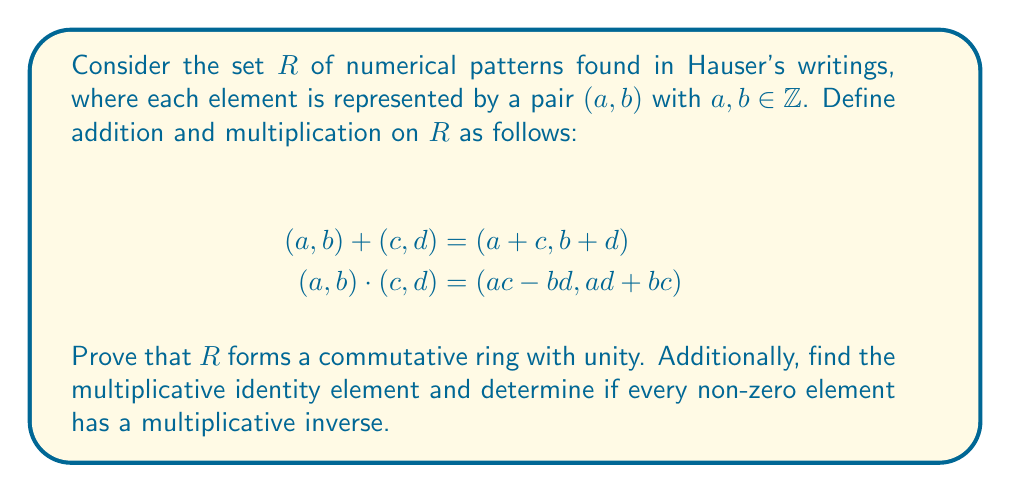Can you answer this question? To prove that $R$ forms a commutative ring with unity, we need to verify the following properties:

1. $(R,+)$ is an abelian group:
   a) Closure: For any $(a,b), (c,d) \in R$, $(a+c, b+d) \in R$.
   b) Associativity: $((a,b) + (c,d)) + (e,f) = (a,b) + ((c,d) + (e,f))$.
   c) Commutativity: $(a,b) + (c,d) = (c,d) + (a,b)$.
   d) Identity: $(0,0)$ is the additive identity.
   e) Inverse: For any $(a,b) \in R$, $(-a,-b)$ is its additive inverse.

2. $(R,\cdot)$ is commutative:
   $(a,b) \cdot (c,d) = (ac-bd, ad+bc) = (ca-db, cb+da) = (c,d) \cdot (a,b)$

3. Multiplication is associative:
   $((a,b) \cdot (c,d)) \cdot (e,f) = (a,b) \cdot ((c,d) \cdot (e,f))$

4. Distributive laws:
   $(a,b) \cdot ((c,d) + (e,f)) = (a,b) \cdot (c,d) + (a,b) \cdot (e,f)$
   $((a,b) + (c,d)) \cdot (e,f) = (a,b) \cdot (e,f) + (c,d) \cdot (e,f)$

5. Multiplicative identity:
   The element $(1,0)$ serves as the multiplicative identity because:
   $(1,0) \cdot (a,b) = (1a-0b, 1b+0a) = (a,b)$

6. Multiplicative inverse:
   For a non-zero element $(a,b)$, its multiplicative inverse (if it exists) would be $(\frac{a}{a^2+b^2}, \frac{-b}{a^2+b^2})$. However, this is not always an element of $R$ because the fractions may not be integers.

Therefore, $R$ forms a commutative ring with unity, but not every non-zero element has a multiplicative inverse.
Answer: $R$ is a commutative ring with unity. The multiplicative identity is $(1,0)$. Not every non-zero element has a multiplicative inverse, so $R$ is not a field. 